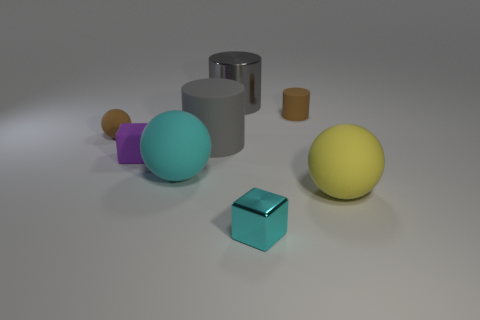Subtract all cyan blocks. How many gray cylinders are left? 2 Subtract all gray cylinders. How many cylinders are left? 1 Subtract 1 balls. How many balls are left? 2 Add 1 tiny cyan metal objects. How many objects exist? 9 Subtract all balls. How many objects are left? 5 Subtract all green cylinders. Subtract all yellow balls. How many cylinders are left? 3 Add 8 gray metal cylinders. How many gray metal cylinders are left? 9 Add 8 big yellow metal objects. How many big yellow metal objects exist? 8 Subtract 1 brown cylinders. How many objects are left? 7 Subtract all large gray rubber cylinders. Subtract all purple rubber things. How many objects are left? 6 